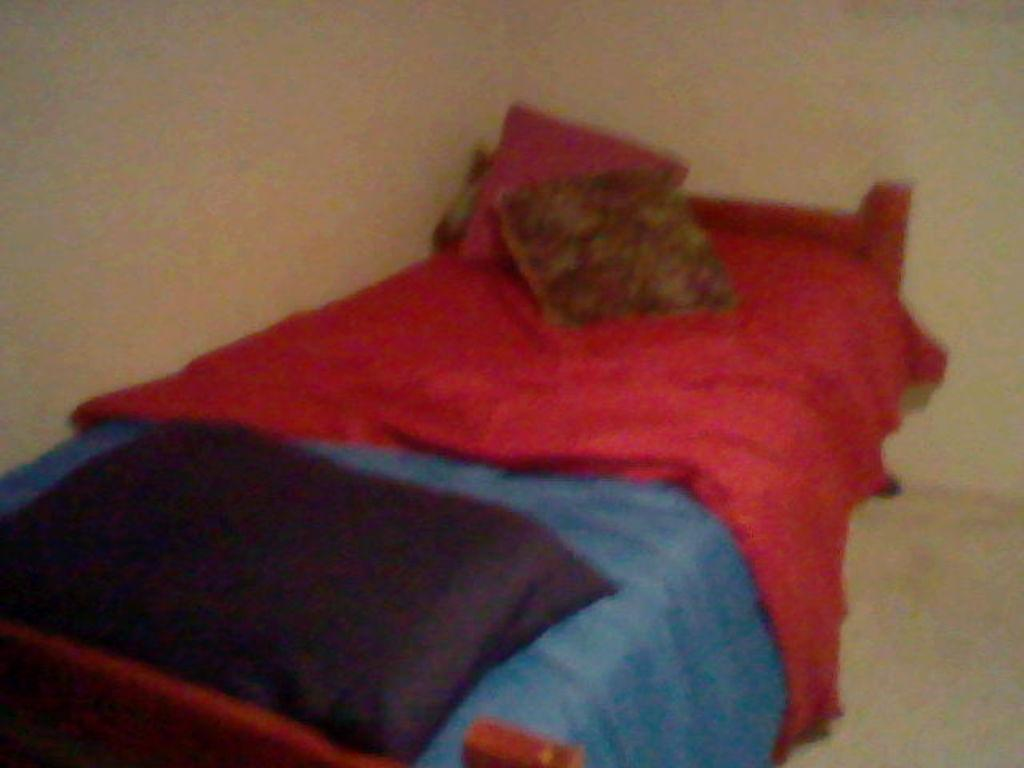What type of furniture is present in the image? There is a bed in the image. What is placed on the bed? There are pillows on the bed. What type of government is depicted in the image? There is no depiction of a government in the image; it features a bed with pillows. What kind of meat can be seen on the bed in the image? There is no meat present in the image; it only features a bed and pillows. 